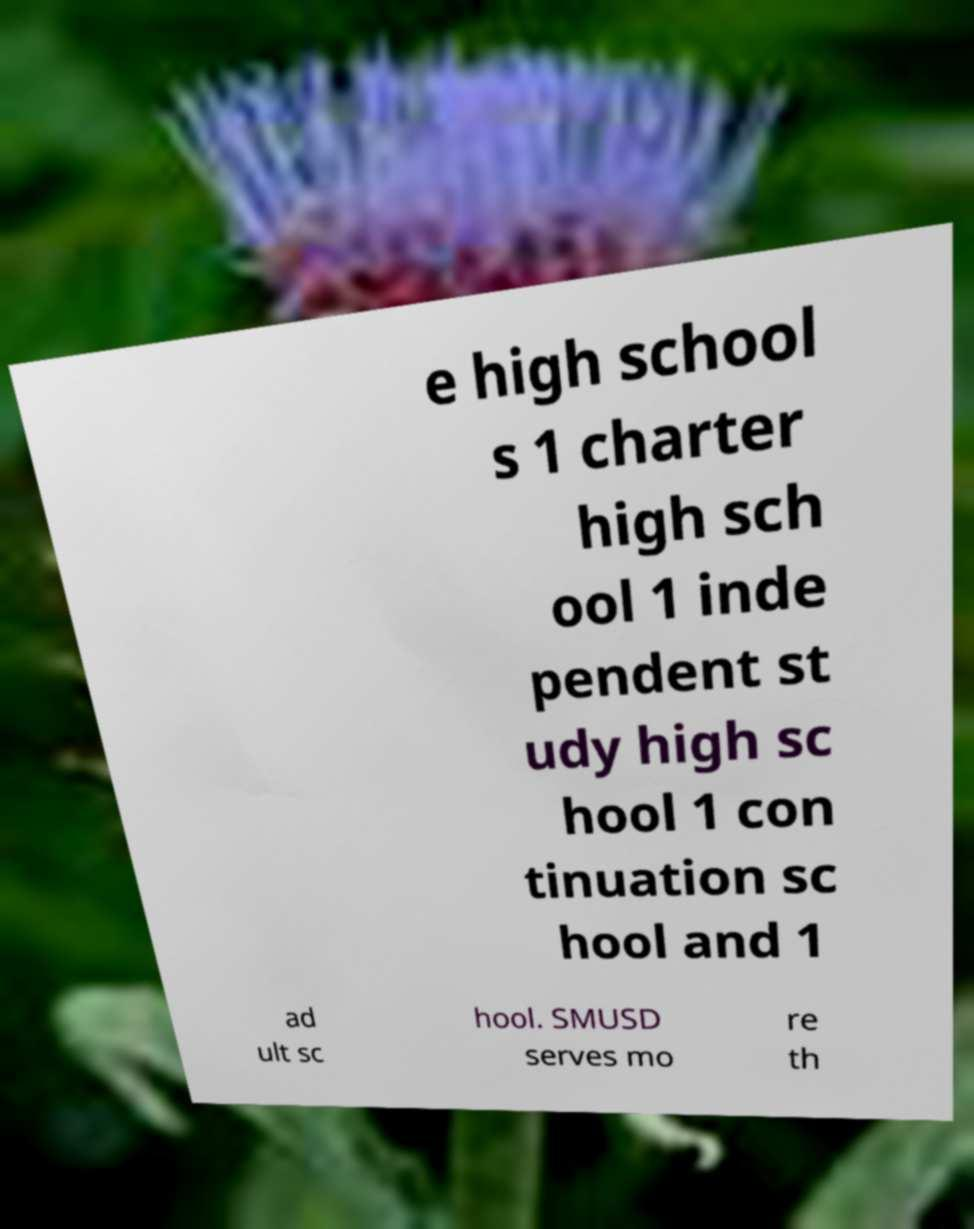Please read and relay the text visible in this image. What does it say? e high school s 1 charter high sch ool 1 inde pendent st udy high sc hool 1 con tinuation sc hool and 1 ad ult sc hool. SMUSD serves mo re th 